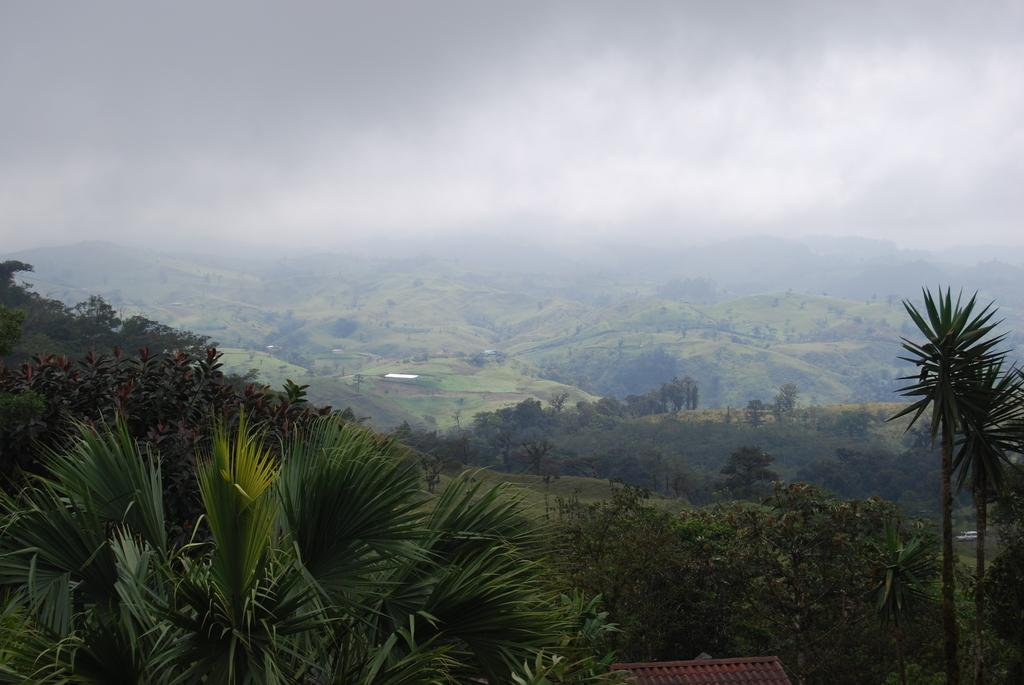What type of vegetation can be seen in the foreground of the image? There is greenery in the foreground of the image. What type of landscape is visible in the background of the image? There are mountains with greenery in the background of the image. How would you describe the sky in the image? The sky is visible in the background of the image and appears foggy. Can you see a girl sleeping on the coast in the image? There is no girl or coast present in the image; it features greenery in the foreground and mountains with greenery in the background, with a foggy sky in the background. 